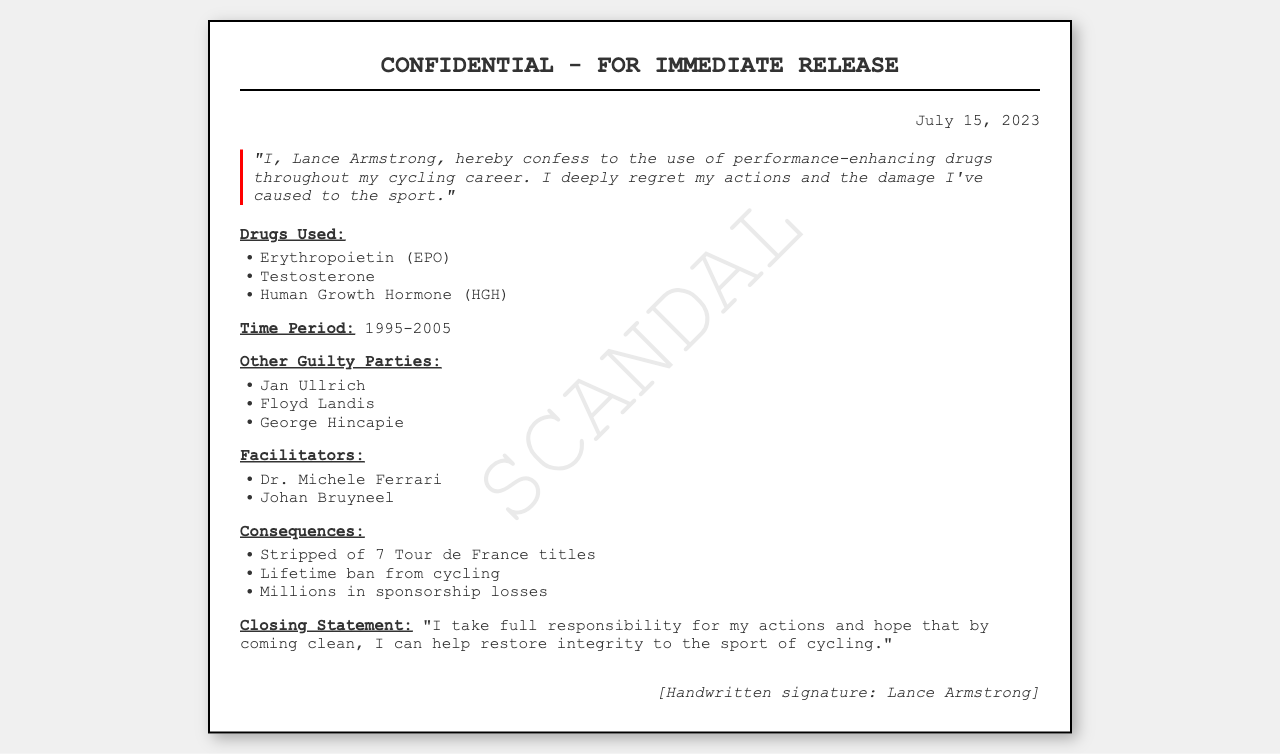What is the name of the athlete confessing? The athlete making the confession is identified as Lance Armstrong in the document.
Answer: Lance Armstrong What substances are mentioned in the confession? The confession lists three specific drugs used: Erythropoietin (EPO), Testosterone, and Human Growth Hormone (HGH).
Answer: Erythropoietin (EPO), Testosterone, Human Growth Hormone (HGH) What year range does the steroid use cover? The confession specifies the time period during which the athlete claims to have used performance-enhancing drugs as 1995-2005.
Answer: 1995-2005 Who is one of the facilitators mentioned? The document names Dr. Michele Ferrari as one of the facilitators involved in the athlete's steroid use.
Answer: Dr. Michele Ferrari How many Tour de France titles was Lance Armstrong stripped of? The document mentions that he was stripped of seven Tour de France titles as a consequence of his actions.
Answer: 7 Which other athletes are named as guilty parties? The confession identifies Jan Ullrich, Floyd Landis, and George Hincapie as additional guilty parties.
Answer: Jan Ullrich, Floyd Landis, George Hincapie What is the closing statement about? The closing statement expresses the athlete's desire to take responsibility and restore integrity to cycling.
Answer: Responsibility and integrity What date is printed on the document? The date indicated on the document is July 15, 2023.
Answer: July 15, 2023 What is the nature of this document? The document is classified as a "CONFIDENTIAL - FOR IMMEDIATE RELEASE" fax, indicating its urgency and sensitivity.
Answer: Fax 